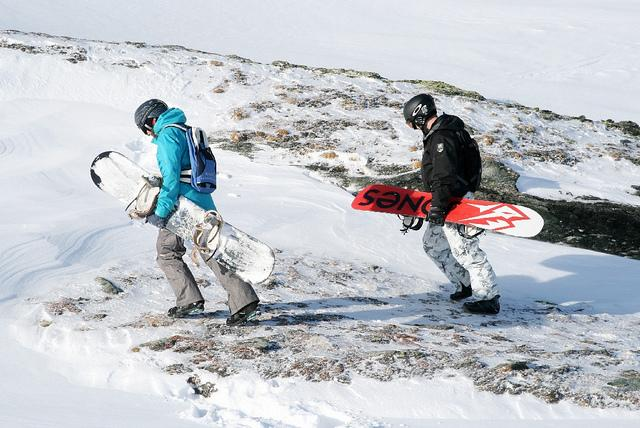What name is on the bottom of the ski board? Please explain your reasoning. jones. The name is jones. 